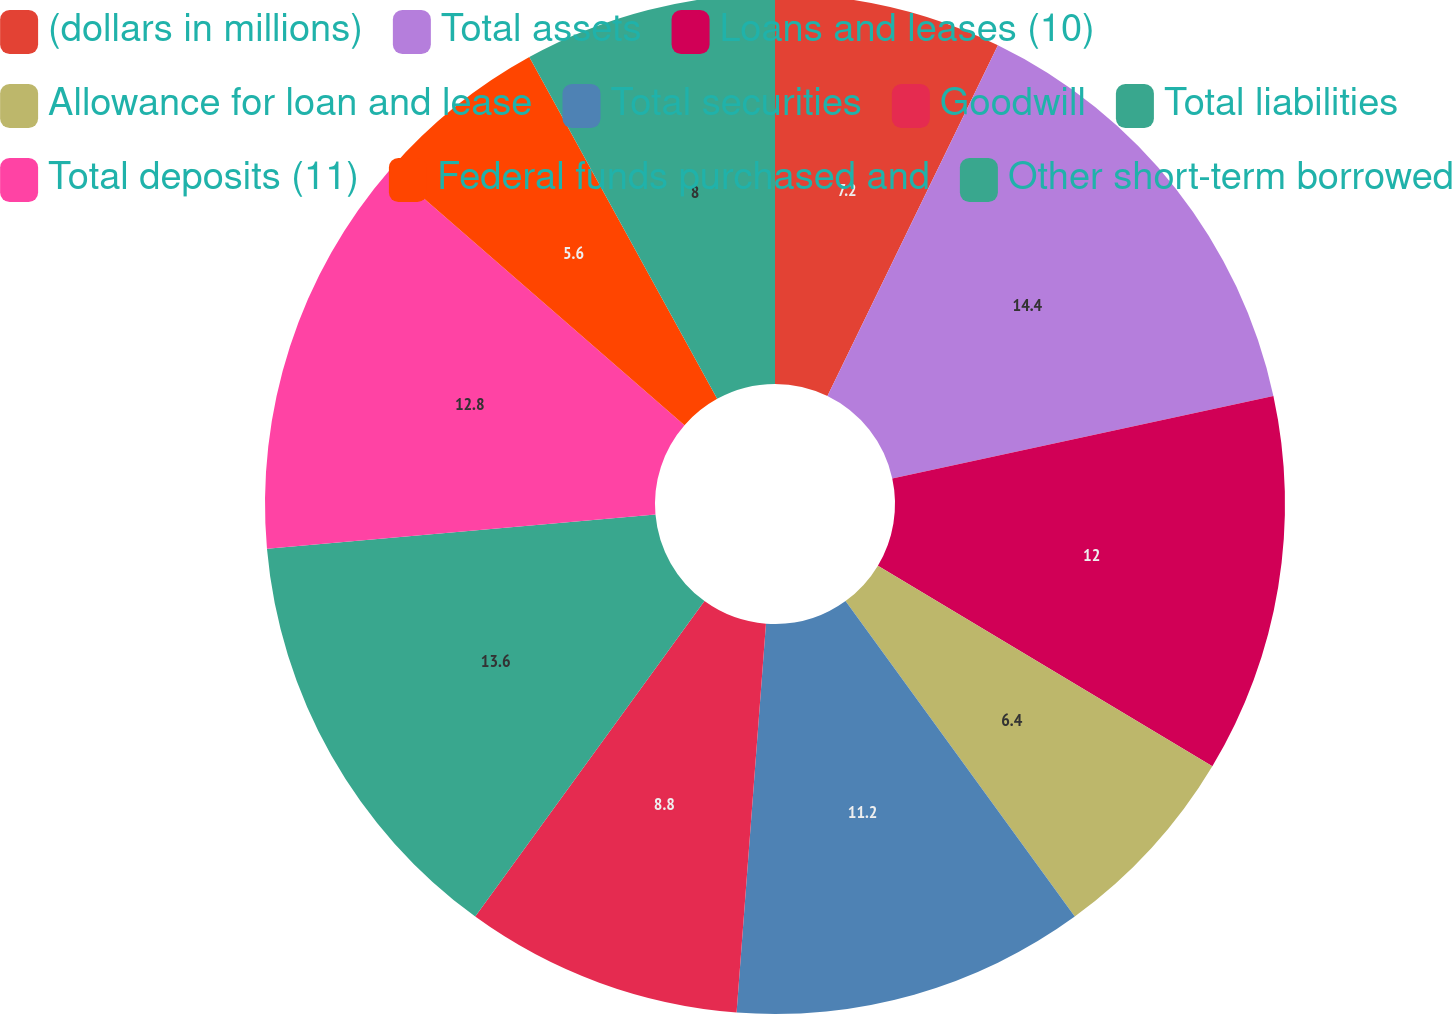<chart> <loc_0><loc_0><loc_500><loc_500><pie_chart><fcel>(dollars in millions)<fcel>Total assets<fcel>Loans and leases (10)<fcel>Allowance for loan and lease<fcel>Total securities<fcel>Goodwill<fcel>Total liabilities<fcel>Total deposits (11)<fcel>Federal funds purchased and<fcel>Other short-term borrowed<nl><fcel>7.2%<fcel>14.4%<fcel>12.0%<fcel>6.4%<fcel>11.2%<fcel>8.8%<fcel>13.6%<fcel>12.8%<fcel>5.6%<fcel>8.0%<nl></chart> 